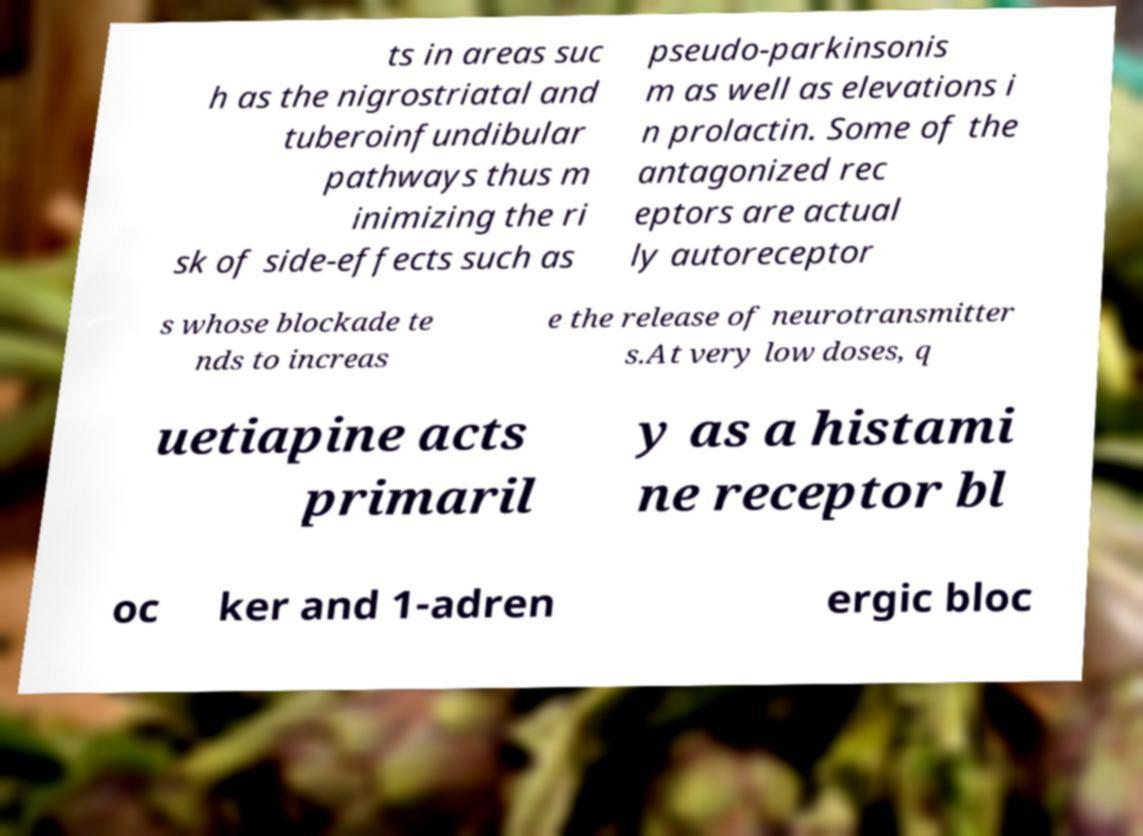There's text embedded in this image that I need extracted. Can you transcribe it verbatim? ts in areas suc h as the nigrostriatal and tuberoinfundibular pathways thus m inimizing the ri sk of side-effects such as pseudo-parkinsonis m as well as elevations i n prolactin. Some of the antagonized rec eptors are actual ly autoreceptor s whose blockade te nds to increas e the release of neurotransmitter s.At very low doses, q uetiapine acts primaril y as a histami ne receptor bl oc ker and 1-adren ergic bloc 